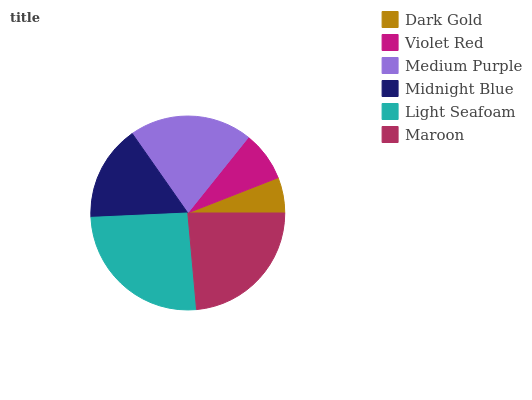Is Dark Gold the minimum?
Answer yes or no. Yes. Is Light Seafoam the maximum?
Answer yes or no. Yes. Is Violet Red the minimum?
Answer yes or no. No. Is Violet Red the maximum?
Answer yes or no. No. Is Violet Red greater than Dark Gold?
Answer yes or no. Yes. Is Dark Gold less than Violet Red?
Answer yes or no. Yes. Is Dark Gold greater than Violet Red?
Answer yes or no. No. Is Violet Red less than Dark Gold?
Answer yes or no. No. Is Medium Purple the high median?
Answer yes or no. Yes. Is Midnight Blue the low median?
Answer yes or no. Yes. Is Light Seafoam the high median?
Answer yes or no. No. Is Medium Purple the low median?
Answer yes or no. No. 